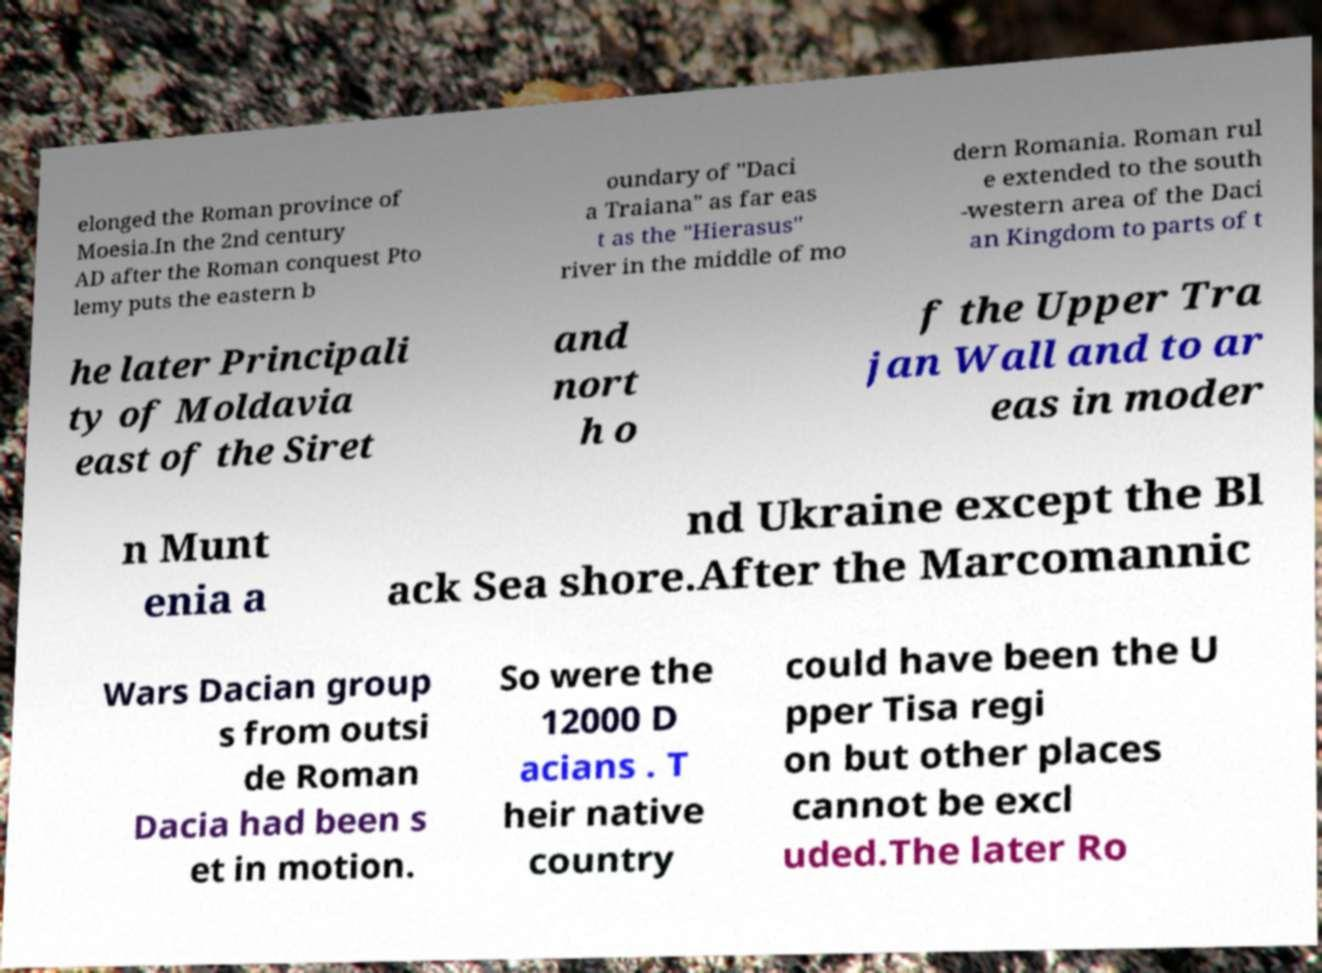What messages or text are displayed in this image? I need them in a readable, typed format. elonged the Roman province of Moesia.In the 2nd century AD after the Roman conquest Pto lemy puts the eastern b oundary of "Daci a Traiana" as far eas t as the "Hierasus" river in the middle of mo dern Romania. Roman rul e extended to the south -western area of the Daci an Kingdom to parts of t he later Principali ty of Moldavia east of the Siret and nort h o f the Upper Tra jan Wall and to ar eas in moder n Munt enia a nd Ukraine except the Bl ack Sea shore.After the Marcomannic Wars Dacian group s from outsi de Roman Dacia had been s et in motion. So were the 12000 D acians . T heir native country could have been the U pper Tisa regi on but other places cannot be excl uded.The later Ro 